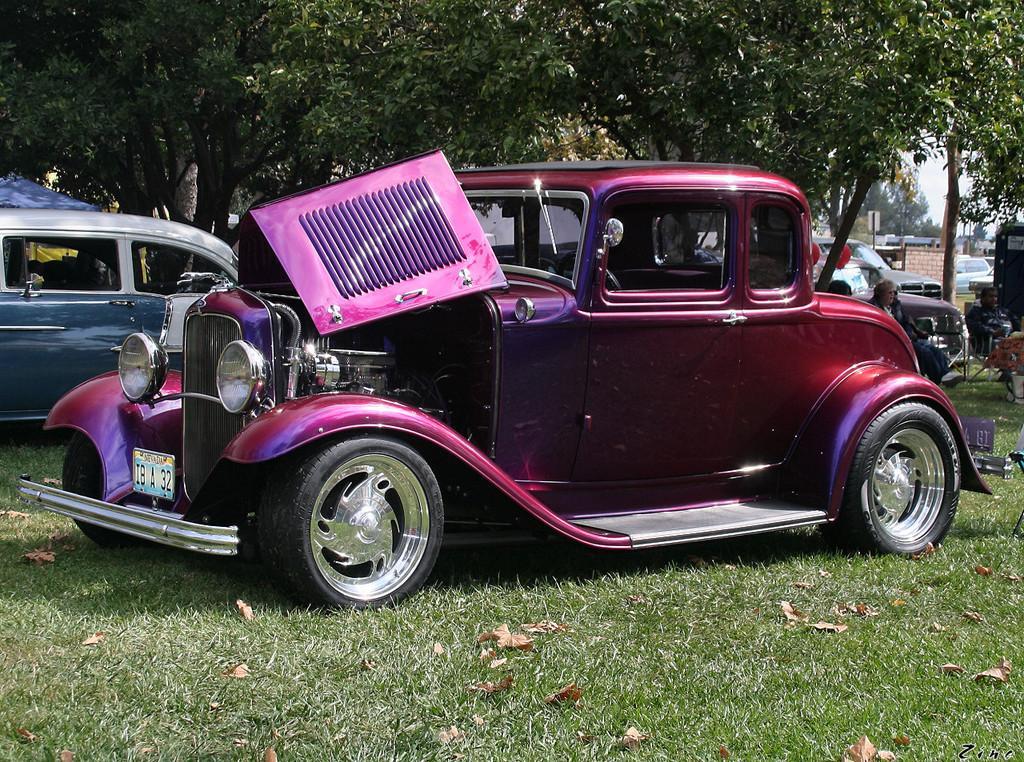Could you give a brief overview of what you see in this image? In this image we can see few vehicles, two persons sitting on the chairs, grass, trees, few objects and the sky in the background. 